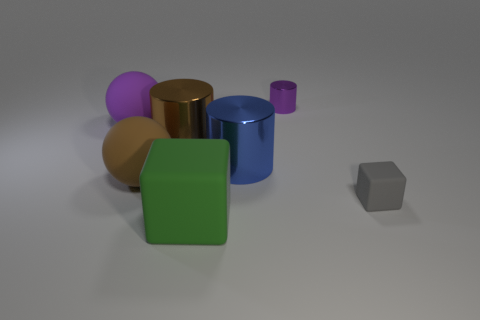Subtract all large cylinders. How many cylinders are left? 1 Subtract 1 cylinders. How many cylinders are left? 2 Add 3 large blue things. How many objects exist? 10 Subtract all cylinders. How many objects are left? 4 Subtract 0 yellow cubes. How many objects are left? 7 Subtract all blue rubber blocks. Subtract all big blocks. How many objects are left? 6 Add 4 big purple rubber things. How many big purple rubber things are left? 5 Add 7 blue metal balls. How many blue metal balls exist? 7 